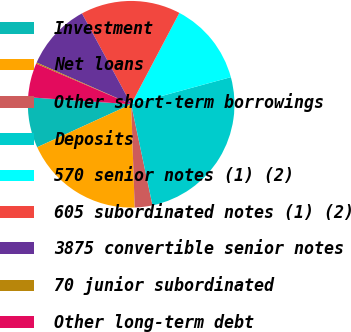<chart> <loc_0><loc_0><loc_500><loc_500><pie_chart><fcel>Investment<fcel>Net loans<fcel>Other short-term borrowings<fcel>Deposits<fcel>570 senior notes (1) (2)<fcel>605 subordinated notes (1) (2)<fcel>3875 convertible senior notes<fcel>70 junior subordinated<fcel>Other long-term debt<nl><fcel>7.91%<fcel>18.72%<fcel>2.77%<fcel>25.91%<fcel>13.05%<fcel>15.63%<fcel>10.48%<fcel>0.19%<fcel>5.34%<nl></chart> 